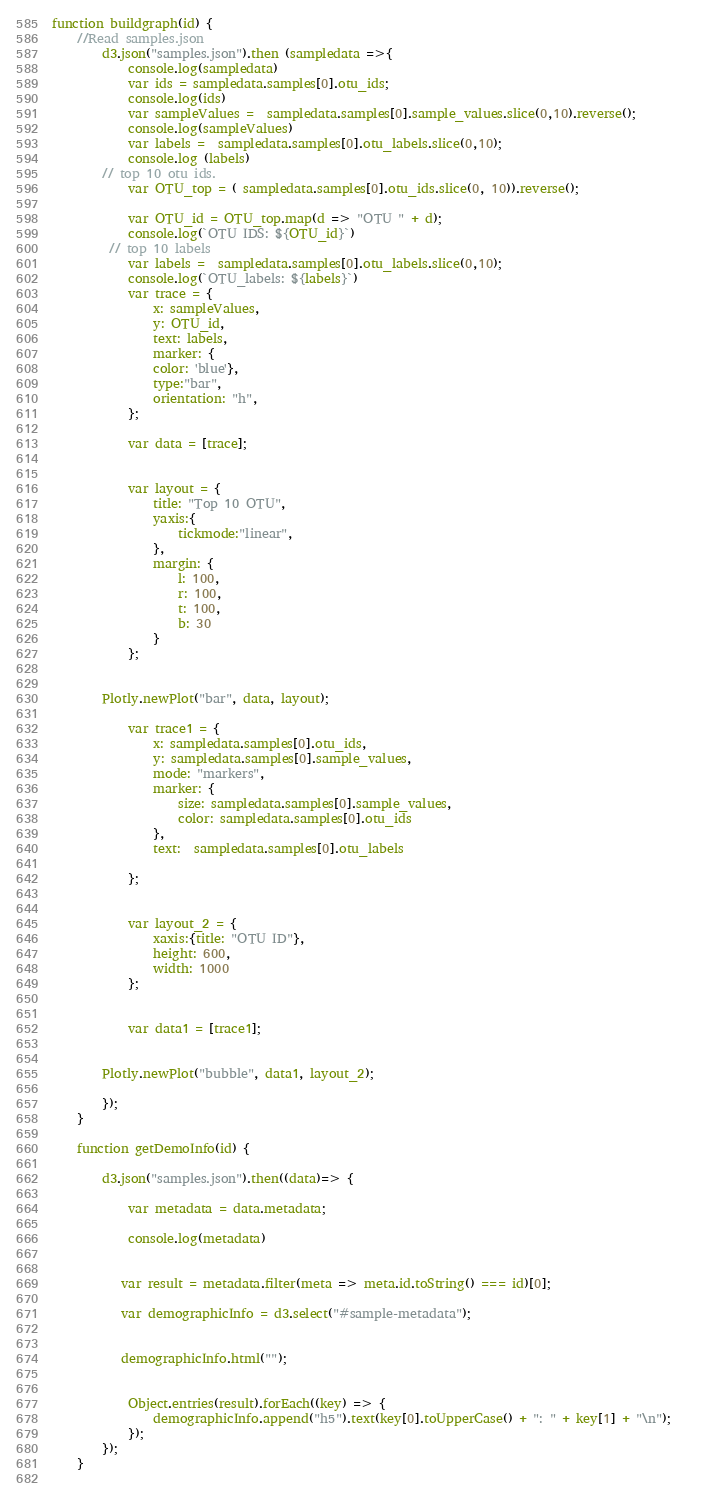<code> <loc_0><loc_0><loc_500><loc_500><_JavaScript_>function buildgraph(id) {
    //Read samples.json
        d3.json("samples.json").then (sampledata =>{
            console.log(sampledata)
            var ids = sampledata.samples[0].otu_ids;
            console.log(ids)
            var sampleValues =  sampledata.samples[0].sample_values.slice(0,10).reverse();
            console.log(sampleValues)
            var labels =  sampledata.samples[0].otu_labels.slice(0,10);
            console.log (labels)
        // top 10 otu ids. 
            var OTU_top = ( sampledata.samples[0].otu_ids.slice(0, 10)).reverse();
        
            var OTU_id = OTU_top.map(d => "OTU " + d);
            console.log(`OTU IDS: ${OTU_id}`)
         // top 10 labels
            var labels =  sampledata.samples[0].otu_labels.slice(0,10);
            console.log(`OTU_labels: ${labels}`)
            var trace = {
                x: sampleValues,
                y: OTU_id,
                text: labels,
                marker: {
                color: 'blue'},
                type:"bar",
                orientation: "h",
            };
          
            var data = [trace];
    
            
            var layout = {
                title: "Top 10 OTU",
                yaxis:{
                    tickmode:"linear",
                },
                margin: {
                    l: 100,
                    r: 100,
                    t: 100,
                    b: 30
                }
            };
    
            
        Plotly.newPlot("bar", data, layout);
            
            var trace1 = {
                x: sampledata.samples[0].otu_ids,
                y: sampledata.samples[0].sample_values,
                mode: "markers",
                marker: {
                    size: sampledata.samples[0].sample_values,
                    color: sampledata.samples[0].otu_ids
                },
                text:  sampledata.samples[0].otu_labels
    
            };
    
            
            var layout_2 = {
                xaxis:{title: "OTU ID"},
                height: 600,
                width: 1000
            };
    
           
            var data1 = [trace1];
    
        
        Plotly.newPlot("bubble", data1, layout_2); 
        
        });
    }  
    
    function getDemoInfo(id) {
    
        d3.json("samples.json").then((data)=> {
    
            var metadata = data.metadata;
    
            console.log(metadata)
    
          
           var result = metadata.filter(meta => meta.id.toString() === id)[0];
          
           var demographicInfo = d3.select("#sample-metadata");
            
        
           demographicInfo.html("");
    
         
            Object.entries(result).forEach((key) => {   
                demographicInfo.append("h5").text(key[0].toUpperCase() + ": " + key[1] + "\n");    
            });
        });
    }
    </code> 